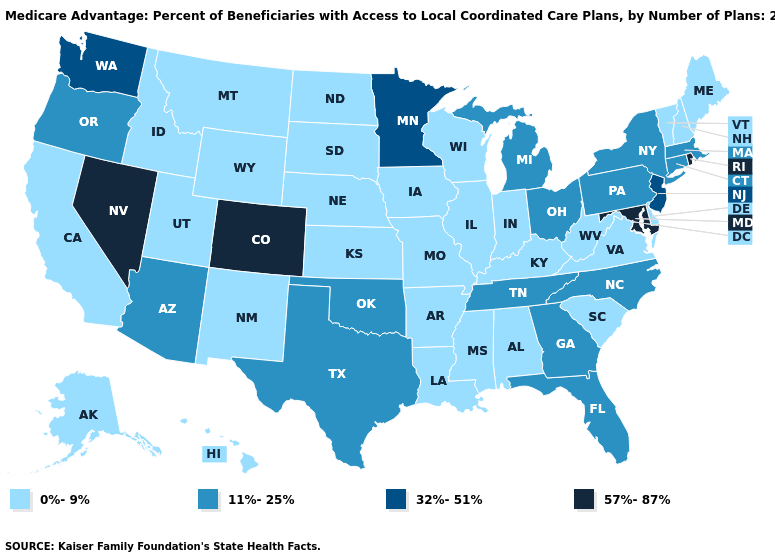Does North Dakota have a lower value than Idaho?
Quick response, please. No. Among the states that border Arkansas , does Texas have the highest value?
Short answer required. Yes. Name the states that have a value in the range 32%-51%?
Give a very brief answer. Minnesota, New Jersey, Washington. What is the value of New Hampshire?
Answer briefly. 0%-9%. Which states have the lowest value in the South?
Keep it brief. Alabama, Arkansas, Delaware, Kentucky, Louisiana, Mississippi, South Carolina, Virginia, West Virginia. What is the value of Virginia?
Short answer required. 0%-9%. What is the value of South Carolina?
Answer briefly. 0%-9%. What is the lowest value in the USA?
Quick response, please. 0%-9%. Name the states that have a value in the range 0%-9%?
Keep it brief. Alaska, Alabama, Arkansas, California, Delaware, Hawaii, Iowa, Idaho, Illinois, Indiana, Kansas, Kentucky, Louisiana, Maine, Missouri, Mississippi, Montana, North Dakota, Nebraska, New Hampshire, New Mexico, South Carolina, South Dakota, Utah, Virginia, Vermont, Wisconsin, West Virginia, Wyoming. Does the map have missing data?
Answer briefly. No. Among the states that border Arkansas , does Texas have the highest value?
Short answer required. Yes. What is the highest value in states that border Connecticut?
Answer briefly. 57%-87%. Does Florida have the same value as California?
Give a very brief answer. No. Name the states that have a value in the range 11%-25%?
Give a very brief answer. Arizona, Connecticut, Florida, Georgia, Massachusetts, Michigan, North Carolina, New York, Ohio, Oklahoma, Oregon, Pennsylvania, Tennessee, Texas. How many symbols are there in the legend?
Write a very short answer. 4. 